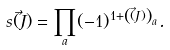Convert formula to latex. <formula><loc_0><loc_0><loc_500><loc_500>s ( \vec { J } ) = \prod _ { a } ( - 1 ) ^ { 1 + \left ( ( \vec { J } ) \right ) _ { a } } .</formula> 